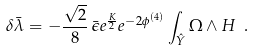Convert formula to latex. <formula><loc_0><loc_0><loc_500><loc_500>\delta \bar { \lambda } = - \frac { \sqrt { 2 } } { 8 } \, \bar { \epsilon } e ^ { \frac { K } { 2 } } e ^ { - 2 \phi ^ { ( 4 ) } } \int _ { \hat { Y } } \Omega \wedge H \ .</formula> 